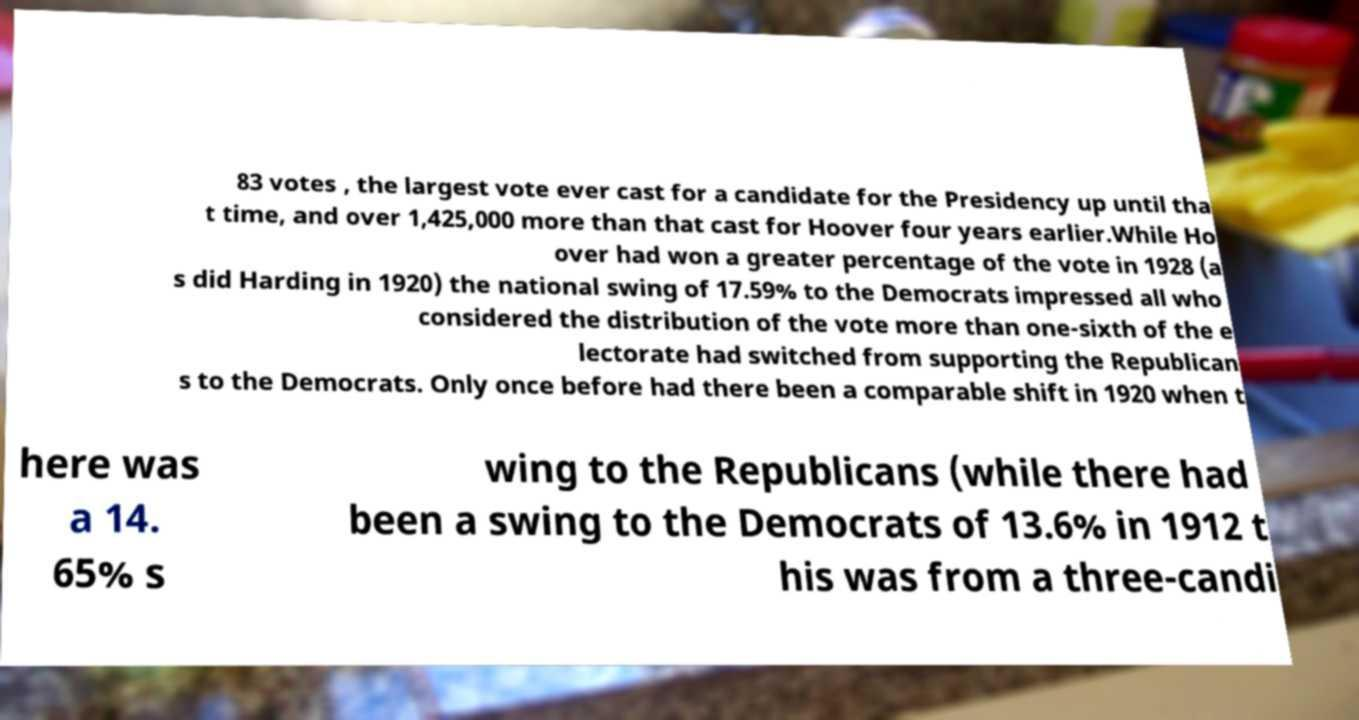Please identify and transcribe the text found in this image. 83 votes , the largest vote ever cast for a candidate for the Presidency up until tha t time, and over 1,425,000 more than that cast for Hoover four years earlier.While Ho over had won a greater percentage of the vote in 1928 (a s did Harding in 1920) the national swing of 17.59% to the Democrats impressed all who considered the distribution of the vote more than one-sixth of the e lectorate had switched from supporting the Republican s to the Democrats. Only once before had there been a comparable shift in 1920 when t here was a 14. 65% s wing to the Republicans (while there had been a swing to the Democrats of 13.6% in 1912 t his was from a three-candi 